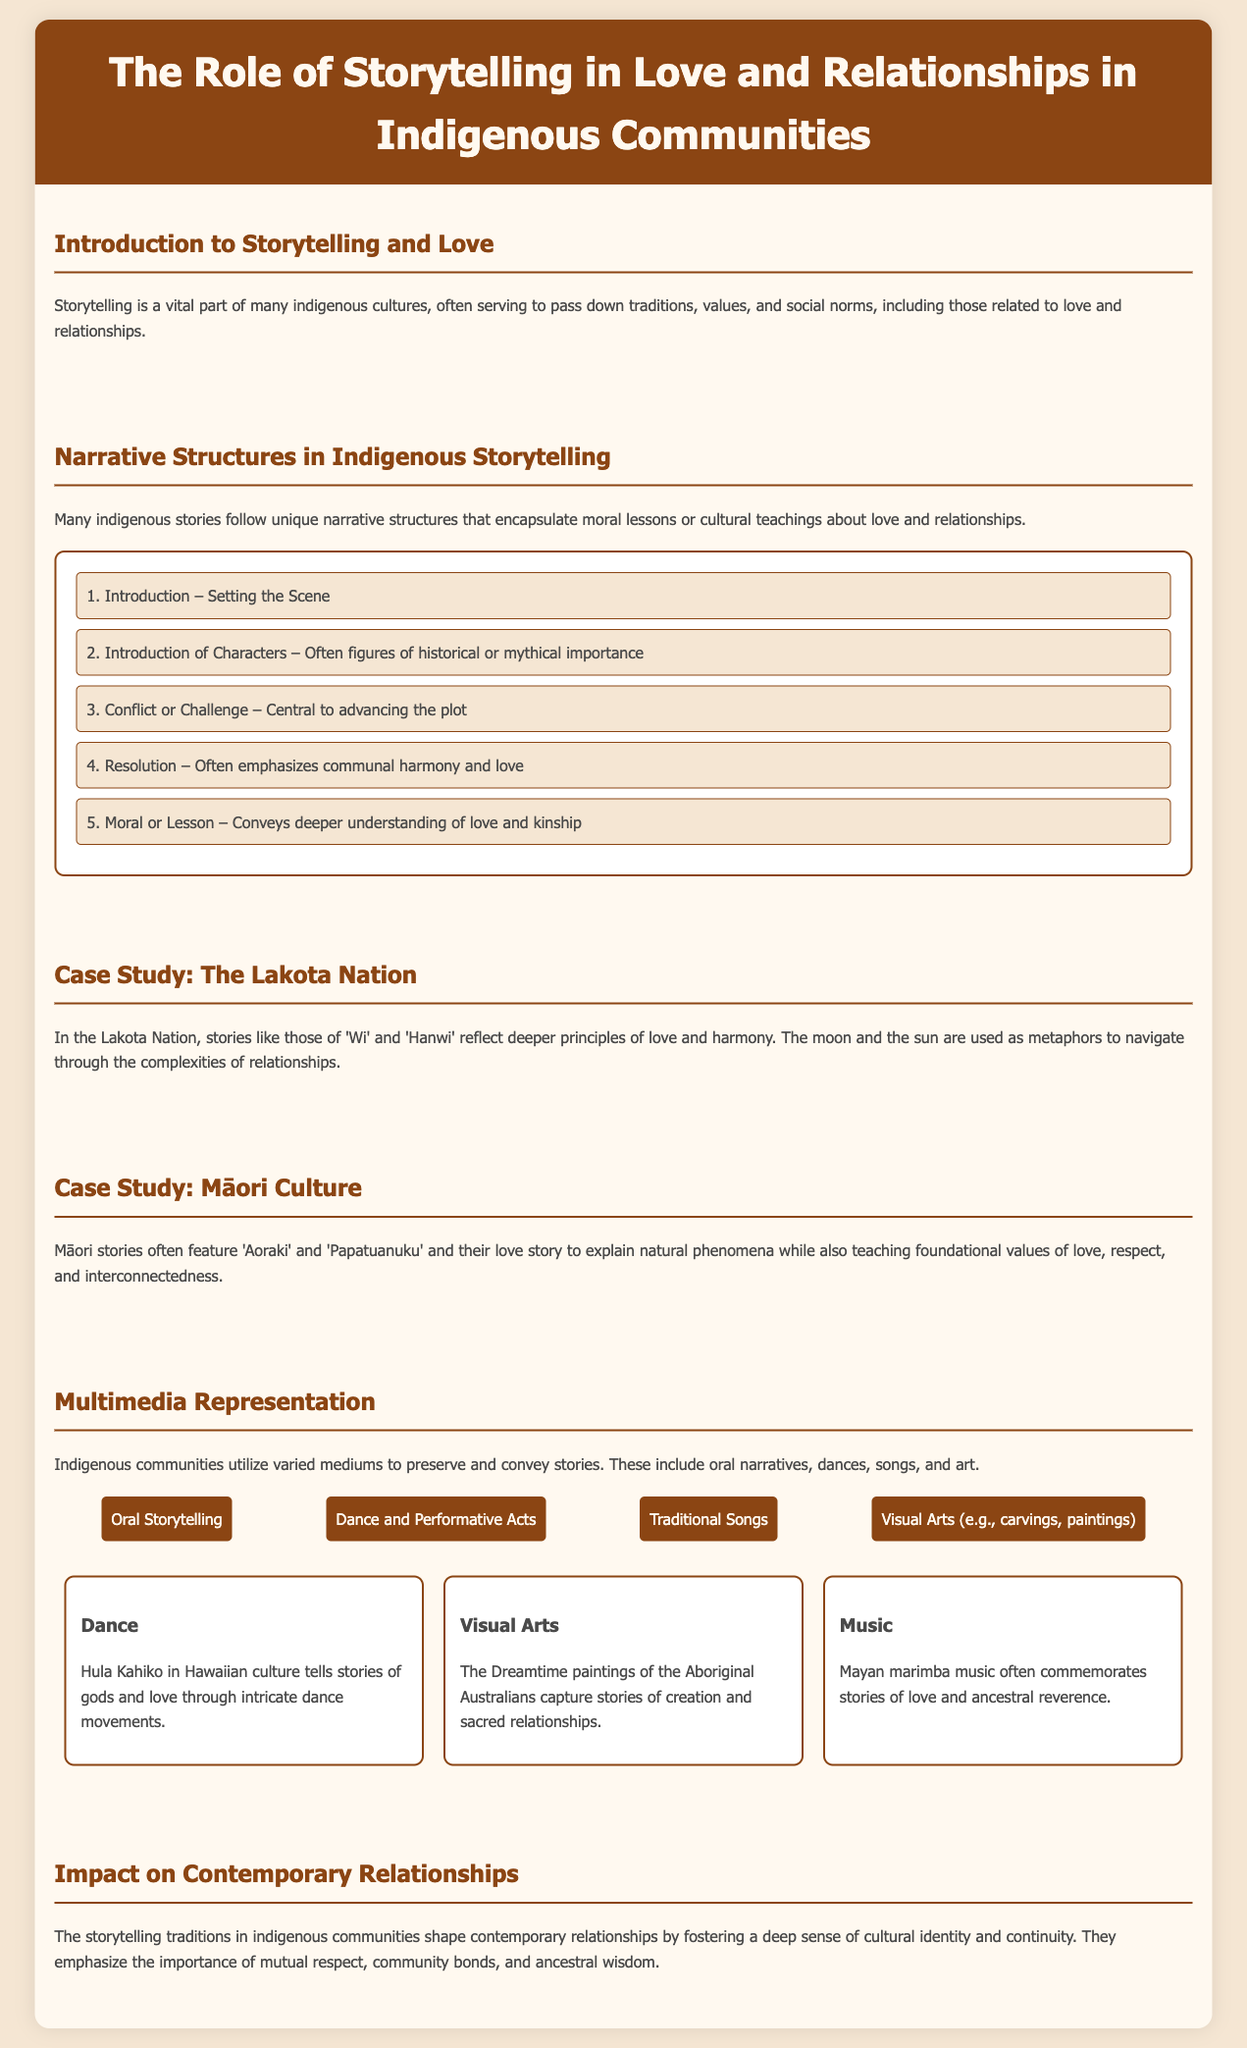what is the title of the infographic? The title of the infographic is presented prominently at the top of the document, stating "The Role of Storytelling in Love and Relationships in Indigenous Communities."
Answer: The Role of Storytelling in Love and Relationships in Indigenous Communities what is the first step in the narrative structure of indigenous storytelling? The first step is detailed in the flowchart under "Narrative Structures in Indigenous Storytelling," which states "1. Introduction – Setting the Scene."
Answer: Introduction – Setting the Scene who are the characters in the Lakota Nation stories? The document specifies that the characters in Lakota Nation stories are often figures of historical or mythical importance, mentioned in the case study section.
Answer: Historical or mythical importance what are the four types of multimedia representation mentioned? The four types of multimedia representation are listed in the "Multimedia Representation" section as Oral Storytelling, Dance and Performative Acts, Traditional Songs, and Visual Arts.
Answer: Oral Storytelling, Dance and Performative Acts, Traditional Songs, Visual Arts what is emphasized in the resolution of indigenous love stories? The resolution often emphasizes a key theme as indicated in the narrative structure section, which specifies "communal harmony and love."
Answer: Communal harmony and love how does storytelling affect contemporary relationships in indigenous communities? The infographic discusses that storytelling traditions shape relationships by fostering cultural identity and continuity, highlighting key influences that resonate today.
Answer: Cultural identity and continuity what is one of the love stories mentioned in Māori culture? The document references "Aoraki" and "Papatuanuku" as significant figures in Māori love stories.
Answer: Aoraki and Papatuanuku which traditional performative act is highlighted in the multimedia representation? The document mentions "Hula Kahiko" as an example of dance that tells stories of gods and love.
Answer: Hula Kahiko 